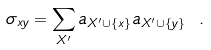Convert formula to latex. <formula><loc_0><loc_0><loc_500><loc_500>\sigma _ { x y } = \sum _ { X ^ { \prime } } a _ { X ^ { \prime } \cup \{ x \} } a _ { X ^ { \prime } \cup \{ y \} } \ .</formula> 